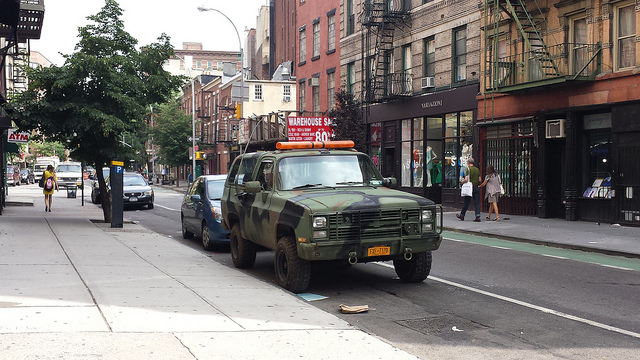Can you describe the setting of this image? The image captures an urban street scene, likely taken in a city based on the storefronts, apartment buildings, and street markings. Pedestrians are visible on the sidewalk, and the setting exudes a typical bustling city atmosphere. Do the buildings have any distinct features that can tell us more about the area? The buildings are a mix of commercial and residential structures, with signage for various businesses, including what seems like a discount store. These elements typically characterize diverse, possibly gentrifying neighborhoods with a mix of local commerce and living spaces. 